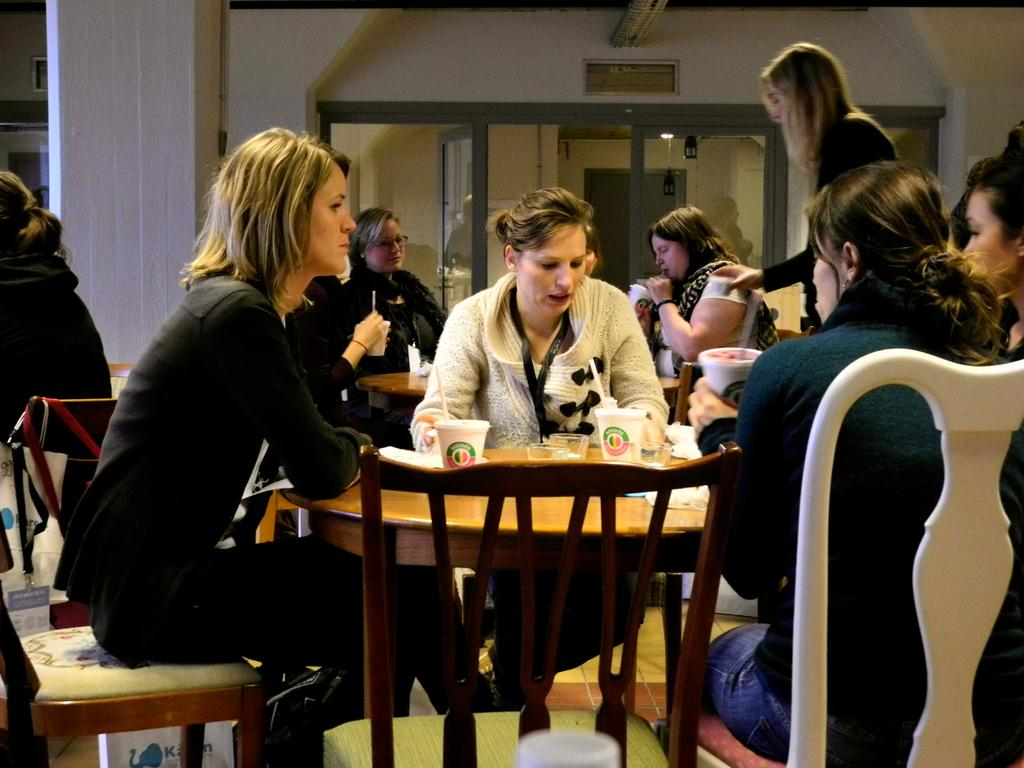What are the people in the image doing? The people in the image are sitting on chairs. What objects can be seen on the table in the image? There are glasses on a table in the image. What type of wine is being served in the glasses on the table? There is no wine present in the image; only glasses can be seen on the table. 